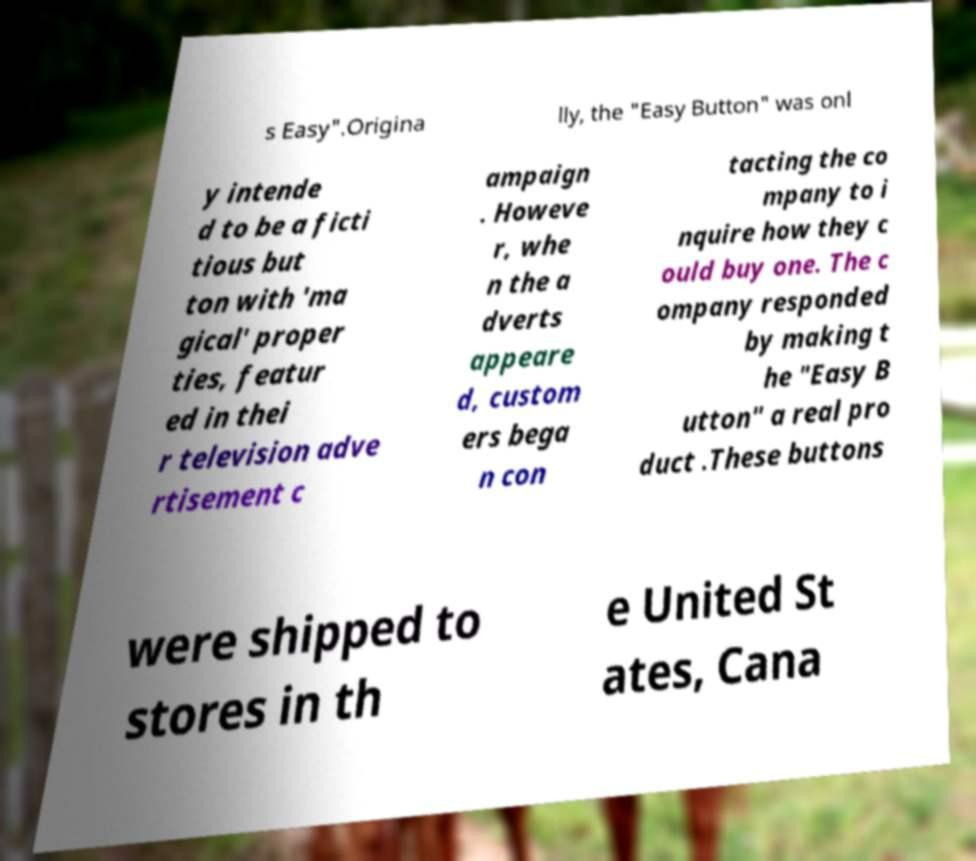For documentation purposes, I need the text within this image transcribed. Could you provide that? s Easy".Origina lly, the "Easy Button" was onl y intende d to be a ficti tious but ton with 'ma gical' proper ties, featur ed in thei r television adve rtisement c ampaign . Howeve r, whe n the a dverts appeare d, custom ers bega n con tacting the co mpany to i nquire how they c ould buy one. The c ompany responded by making t he "Easy B utton" a real pro duct .These buttons were shipped to stores in th e United St ates, Cana 